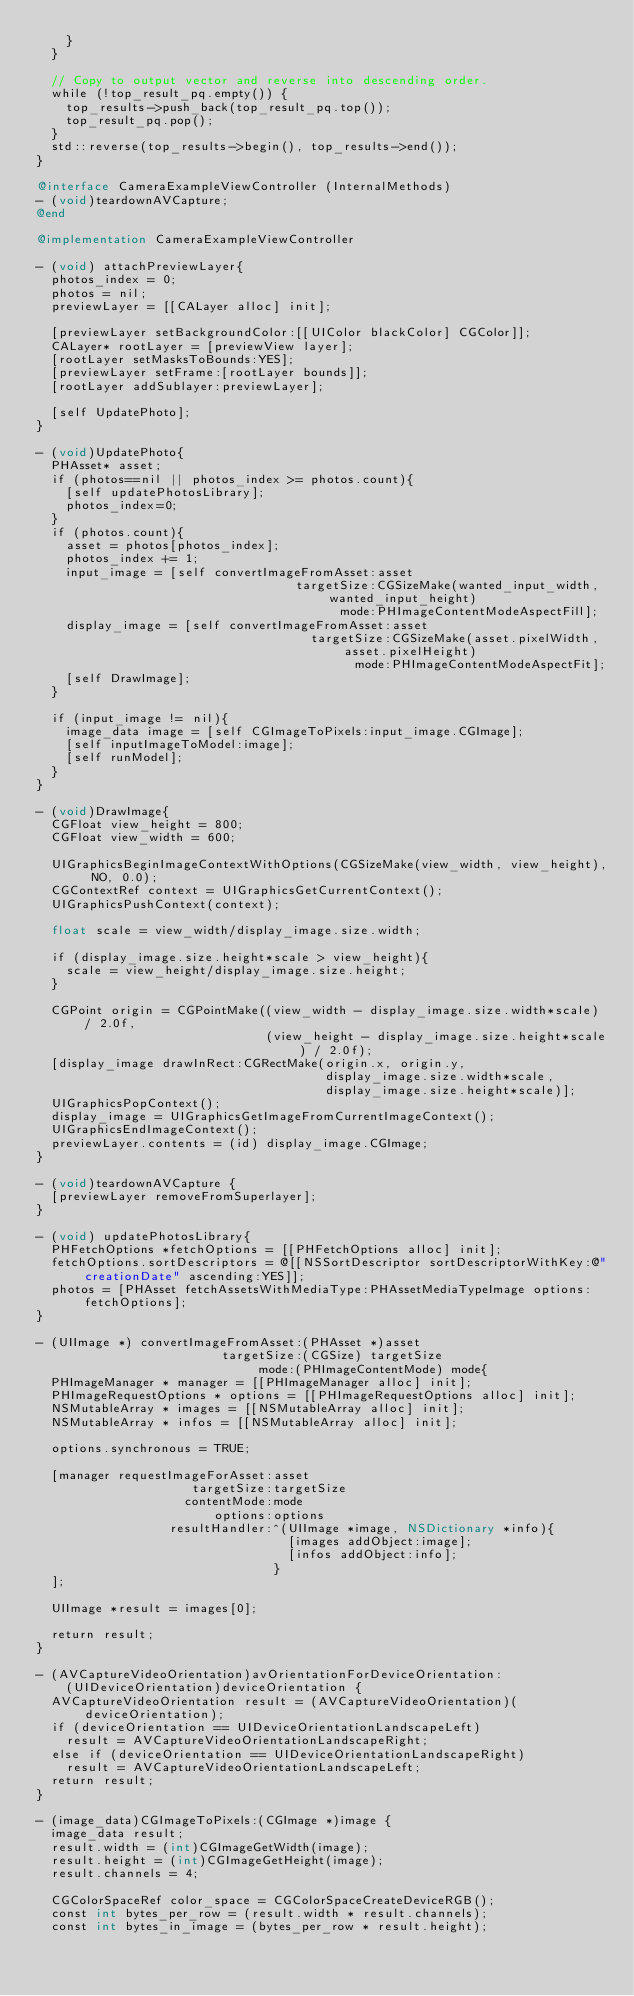Convert code to text. <code><loc_0><loc_0><loc_500><loc_500><_ObjectiveC_>    }
  }

  // Copy to output vector and reverse into descending order.
  while (!top_result_pq.empty()) {
    top_results->push_back(top_result_pq.top());
    top_result_pq.pop();
  }
  std::reverse(top_results->begin(), top_results->end());
}

@interface CameraExampleViewController (InternalMethods)
- (void)teardownAVCapture;
@end

@implementation CameraExampleViewController

- (void) attachPreviewLayer{
  photos_index = 0;
  photos = nil;
  previewLayer = [[CALayer alloc] init];
  
  [previewLayer setBackgroundColor:[[UIColor blackColor] CGColor]];
  CALayer* rootLayer = [previewView layer];
  [rootLayer setMasksToBounds:YES];
  [previewLayer setFrame:[rootLayer bounds]];
  [rootLayer addSublayer:previewLayer];
  
  [self UpdatePhoto];
}

- (void)UpdatePhoto{
  PHAsset* asset;
  if (photos==nil || photos_index >= photos.count){
    [self updatePhotosLibrary];
    photos_index=0;
  }
  if (photos.count){
    asset = photos[photos_index];
    photos_index += 1;
    input_image = [self convertImageFromAsset:asset
                                   targetSize:CGSizeMake(wanted_input_width, wanted_input_height)
                                         mode:PHImageContentModeAspectFill];
    display_image = [self convertImageFromAsset:asset
                                     targetSize:CGSizeMake(asset.pixelWidth,asset.pixelHeight)
                                           mode:PHImageContentModeAspectFit];
    [self DrawImage];
  }
  
  if (input_image != nil){
    image_data image = [self CGImageToPixels:input_image.CGImage];
    [self inputImageToModel:image];
    [self runModel];
  }
}

- (void)DrawImage{
  CGFloat view_height = 800;
  CGFloat view_width = 600;
  
  UIGraphicsBeginImageContextWithOptions(CGSizeMake(view_width, view_height), NO, 0.0);
  CGContextRef context = UIGraphicsGetCurrentContext();
  UIGraphicsPushContext(context);
  
  float scale = view_width/display_image.size.width;
  
  if (display_image.size.height*scale > view_height){
    scale = view_height/display_image.size.height;
  }
  
  CGPoint origin = CGPointMake((view_width - display_image.size.width*scale) / 2.0f,
                               (view_height - display_image.size.height*scale) / 2.0f);
  [display_image drawInRect:CGRectMake(origin.x, origin.y,
                                       display_image.size.width*scale,
                                       display_image.size.height*scale)];
  UIGraphicsPopContext();
  display_image = UIGraphicsGetImageFromCurrentImageContext();
  UIGraphicsEndImageContext();
  previewLayer.contents = (id) display_image.CGImage;
}

- (void)teardownAVCapture {
  [previewLayer removeFromSuperlayer];
}

- (void) updatePhotosLibrary{
  PHFetchOptions *fetchOptions = [[PHFetchOptions alloc] init];
  fetchOptions.sortDescriptors = @[[NSSortDescriptor sortDescriptorWithKey:@"creationDate" ascending:YES]];
  photos = [PHAsset fetchAssetsWithMediaType:PHAssetMediaTypeImage options:fetchOptions];
}

- (UIImage *) convertImageFromAsset:(PHAsset *)asset
                         targetSize:(CGSize) targetSize
                              mode:(PHImageContentMode) mode{
  PHImageManager * manager = [[PHImageManager alloc] init];
  PHImageRequestOptions * options = [[PHImageRequestOptions alloc] init];
  NSMutableArray * images = [[NSMutableArray alloc] init];
  NSMutableArray * infos = [[NSMutableArray alloc] init];
  
  options.synchronous = TRUE;
      
  [manager requestImageForAsset:asset
                     targetSize:targetSize
                    contentMode:mode
                        options:options
                  resultHandler:^(UIImage *image, NSDictionary *info){
                                  [images addObject:image];
                                  [infos addObject:info];
                                }
  ];
  
  UIImage *result = images[0];

  return result;
}

- (AVCaptureVideoOrientation)avOrientationForDeviceOrientation:
    (UIDeviceOrientation)deviceOrientation {
  AVCaptureVideoOrientation result = (AVCaptureVideoOrientation)(deviceOrientation);
  if (deviceOrientation == UIDeviceOrientationLandscapeLeft)
    result = AVCaptureVideoOrientationLandscapeRight;
  else if (deviceOrientation == UIDeviceOrientationLandscapeRight)
    result = AVCaptureVideoOrientationLandscapeLeft;
  return result;
}

- (image_data)CGImageToPixels:(CGImage *)image {
  image_data result;
  result.width = (int)CGImageGetWidth(image);
  result.height = (int)CGImageGetHeight(image);
  result.channels = 4;
  
  CGColorSpaceRef color_space = CGColorSpaceCreateDeviceRGB();
  const int bytes_per_row = (result.width * result.channels);
  const int bytes_in_image = (bytes_per_row * result.height);</code> 